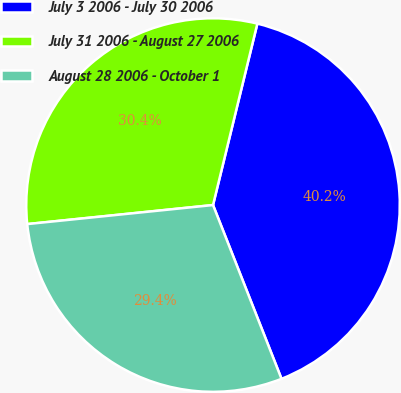Convert chart to OTSL. <chart><loc_0><loc_0><loc_500><loc_500><pie_chart><fcel>July 3 2006 - July 30 2006<fcel>July 31 2006 - August 27 2006<fcel>August 28 2006 - October 1<nl><fcel>40.21%<fcel>30.44%<fcel>29.35%<nl></chart> 